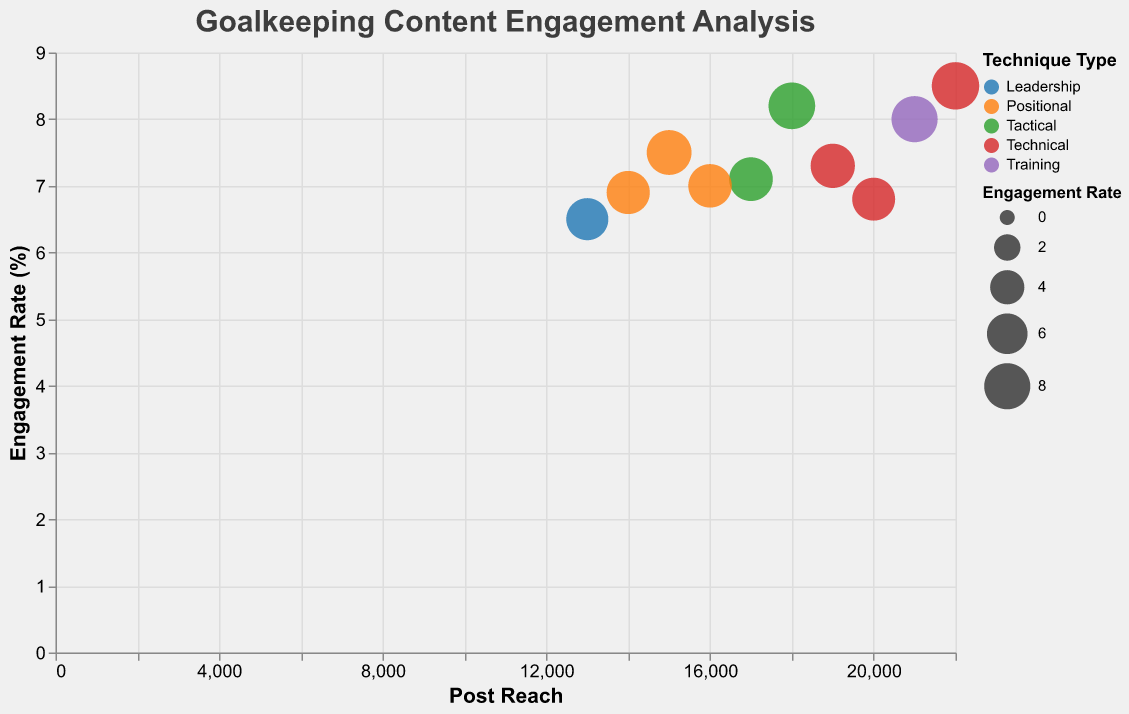What is the title of the figure? The title is usually displayed at the top of the figure. Here, it reads "Goalkeeping Content Engagement Analysis".
Answer: Goalkeeping Content Engagement Analysis How many data points represent "Positional" techniques? Data points representing "Positional" techniques are colored the same. Identify and count them in the figure.
Answer: 3 Which specific technique has the highest Engagement Rate? Look at the y-axis (Engagement Rate) and identify the bubble positioned the highest. Check the tooltip or the color legend to find the specific technique.
Answer: Penalty Saves What's the Engagement Rate for "Diving Saves"? Find the bubble for "Diving Saves" by hovering over the bubbles or using the tooltip feature. The Engagement Rate for this technique should be visible.
Answer: 7.5 Which data point has the smallest Post Reach? Check the x-axis (Post Reach) and find the bubble positioned the furthest left. Use the tooltip to find the corresponding technique and Post Reach value.
Answer: Communication with Defense How does the Post Reach for "Shot-Stopping Drills" compare to "Handling High Balls"? Find the bubbles for both "Shot-Stopping Drills" and "Handling High Balls" using the color legend or tooltips. Compare their positions along the x-axis or use the tooltips to note their Post Reach.
Answer: 21000 (Shot-Stopping Drills) is higher than 20000 (Handling High Balls) What is the average Engagement Rate for the data points provided? Sum up all the Engagement Rates and divide by the number of data points. (7.5 + 8.2 + 6.8 + 7.1 + 8.0 + 6.5 + 7.3 + 7.0 + 8.5 + 6.9) / 10 = 74.8 / 10.
Answer: 7.48 Which technique type tends to have higher engagement rates, "Positional" or "Technical"? Examine and compare the locations and sizes of the bubbles colored for "Positional" and "Technical" techniques, indicating their Engagement Rates. Bubbles for "Technical" techniques like "Penalty Saves" and "Footwork and Movement" appear higher or larger.
Answer: Technical What is the visual size difference between bubbles representing "Cross Collection" and "Penalty Saves"? Bubbles in bubble charts also encode a dimension in their area or radius. Compare the bubble sizes for "Cross Collection" and "Penalty Saves".
Answer: "Penalty Saves" bubble is larger Which technique among Tactical has the lowest engagement rate? First, identify all "Tactical" techniques by color or legend. Check which bubble is placed lowest on the y-axis among "One-on-One Situations", "Distribution and Passing".
Answer: Distribution and Passing 